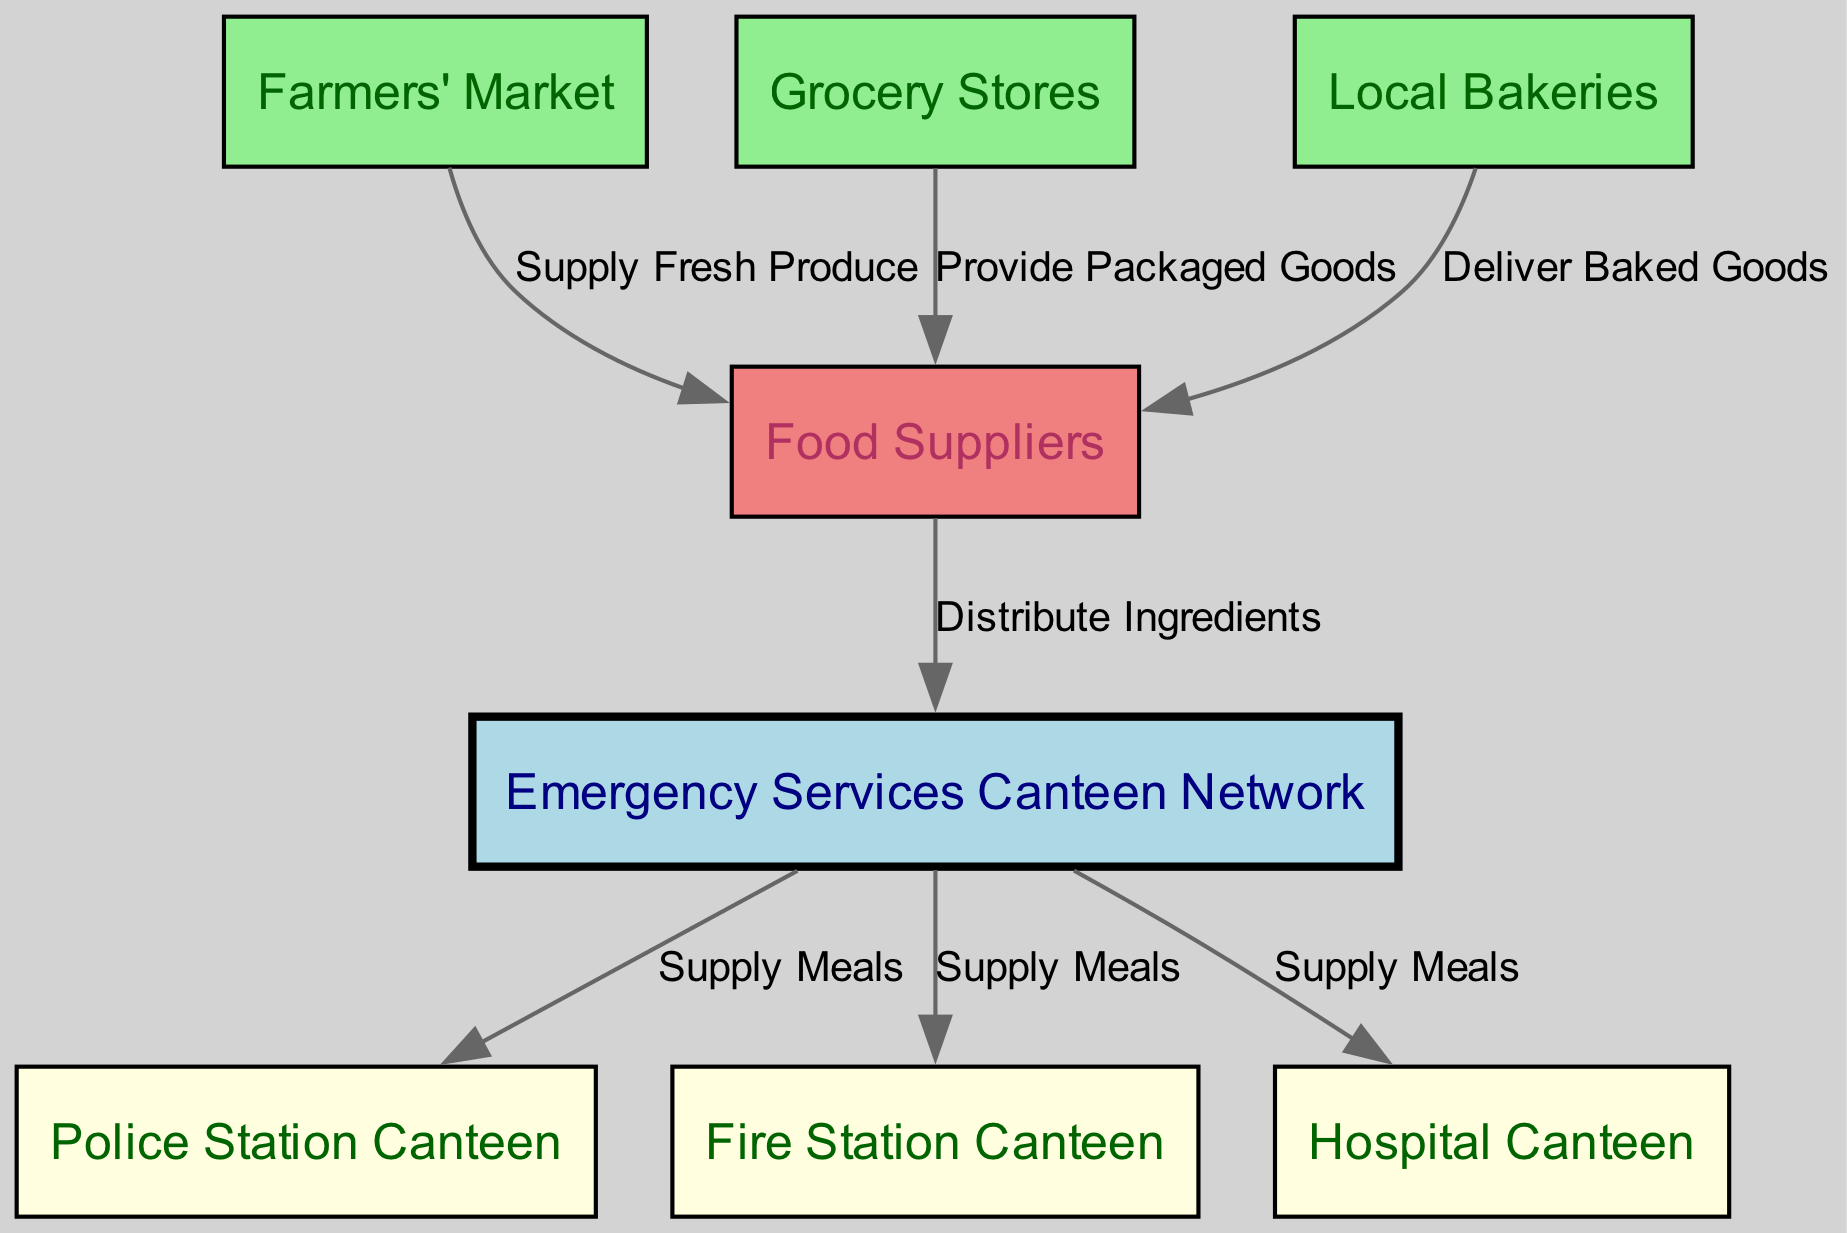What is the central node in the diagram? The central node is the "Emergency Services Canteen Network" as it connects multiple nodes representing different food supplies and recipients within the emergency services.
Answer: Emergency Services Canteen Network How many nodes are there in total? Counting each node listed, such as the canteen, suppliers, and canteens for police, fire, and hospital, there are a total of 8 nodes.
Answer: 8 What food source supplies baked goods? The node labeled "Local Bakeries" specifically delivers baked goods to the supplier in the diagram.
Answer: Local Bakeries Which stations receive meals from the canteen? The diagram shows that meals are supplied to "Police Station Canteen," "Fire Station Canteen," and "Hospital Canteen" directly from the Emergency Services Canteen.
Answer: Police Station Canteen, Fire Station Canteen, Hospital Canteen What type of goods does the grocery store provide? The grocery store provides "Packaged Goods" to the supplier, as indicated on the edge label connecting the grocery store to the supplier node.
Answer: Packaged Goods Which node does the "Farmers' Market" supply? The "Farmers' Market" supplies fresh produce to the "Food Suppliers," as shown in the directed edge from the farmers' market to the supplier.
Answer: Food Suppliers How many edges are present in the diagram? By counting all directed connections from one node to another, there are a total of 7 edges illustrating the relationships in the diagram.
Answer: 7 What connects the supplier to the canteen? The connection from the "Food Suppliers" to the "Emergency Services Canteen Network" represents the distribution of ingredients, as noted on the label of the directed edge.
Answer: Distribute Ingredients Which nodes are directly supplied meals by the canteen? Meals are supplied to three specific nodes: "Police Station Canteen," "Fire Station Canteen," and "Hospital Canteen," indicating a direct delivery of meals.
Answer: Police Station Canteen, Fire Station Canteen, Hospital Canteen What type of farm product does the "Farmers' Market" supply? The "Farmers' Market" defines its supply as "Fresh Produce" in the relationship labeled with the directed edge to the supplier node.
Answer: Fresh Produce 